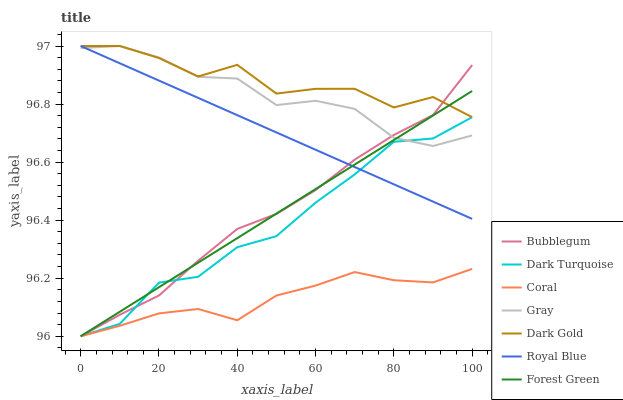Does Coral have the minimum area under the curve?
Answer yes or no. Yes. Does Dark Gold have the maximum area under the curve?
Answer yes or no. Yes. Does Dark Turquoise have the minimum area under the curve?
Answer yes or no. No. Does Dark Turquoise have the maximum area under the curve?
Answer yes or no. No. Is Royal Blue the smoothest?
Answer yes or no. Yes. Is Dark Gold the roughest?
Answer yes or no. Yes. Is Dark Turquoise the smoothest?
Answer yes or no. No. Is Dark Turquoise the roughest?
Answer yes or no. No. Does Dark Turquoise have the lowest value?
Answer yes or no. Yes. Does Dark Gold have the lowest value?
Answer yes or no. No. Does Royal Blue have the highest value?
Answer yes or no. Yes. Does Dark Turquoise have the highest value?
Answer yes or no. No. Is Coral less than Dark Gold?
Answer yes or no. Yes. Is Dark Gold greater than Coral?
Answer yes or no. Yes. Does Forest Green intersect Gray?
Answer yes or no. Yes. Is Forest Green less than Gray?
Answer yes or no. No. Is Forest Green greater than Gray?
Answer yes or no. No. Does Coral intersect Dark Gold?
Answer yes or no. No. 